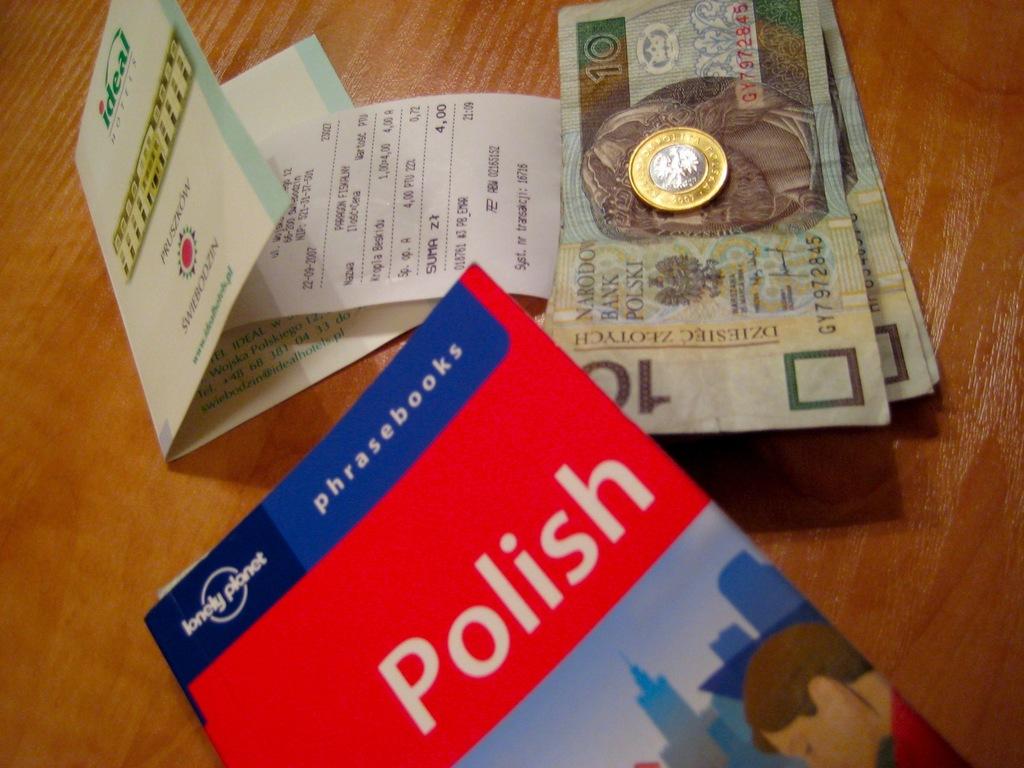What language is the book about?
Ensure brevity in your answer.  Polish. 